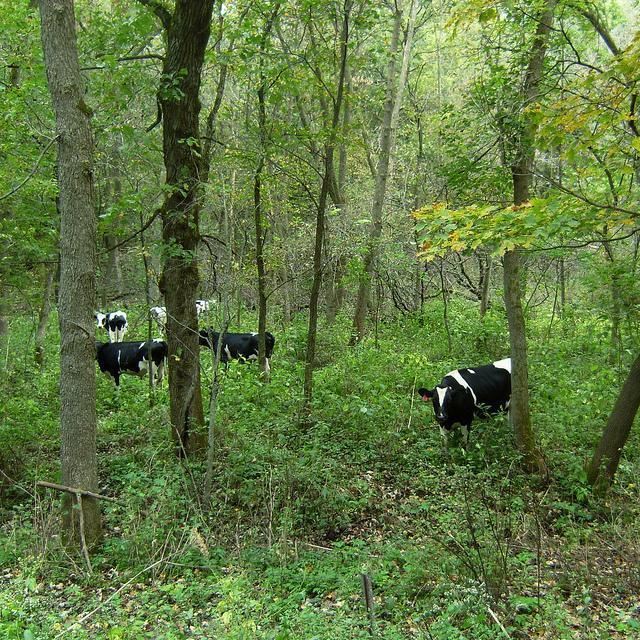How many cows are there?
Give a very brief answer. 2. 